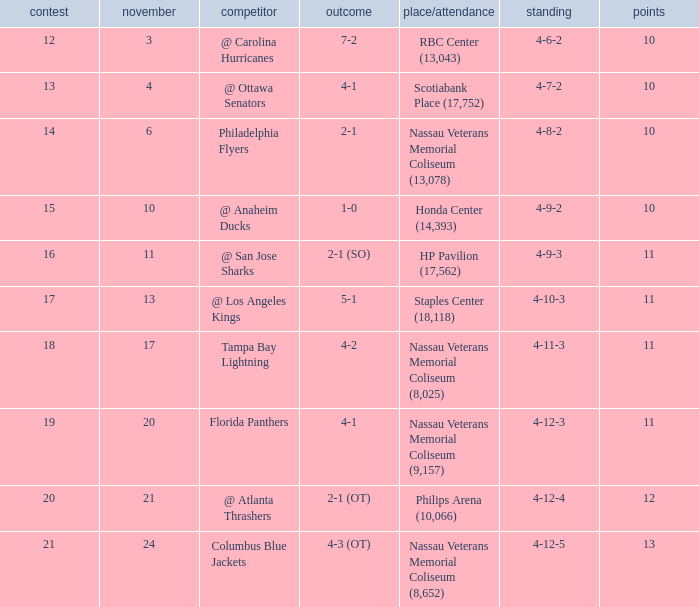What is the minimum number of points? 10.0. 